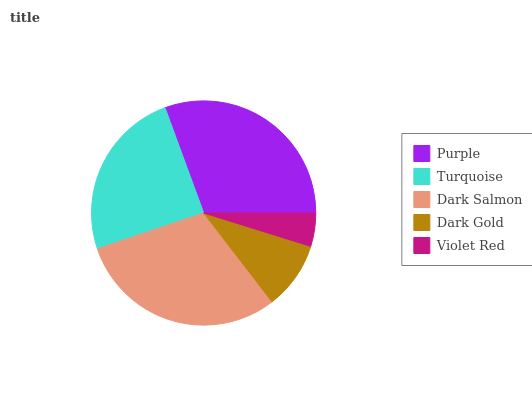Is Violet Red the minimum?
Answer yes or no. Yes. Is Purple the maximum?
Answer yes or no. Yes. Is Turquoise the minimum?
Answer yes or no. No. Is Turquoise the maximum?
Answer yes or no. No. Is Purple greater than Turquoise?
Answer yes or no. Yes. Is Turquoise less than Purple?
Answer yes or no. Yes. Is Turquoise greater than Purple?
Answer yes or no. No. Is Purple less than Turquoise?
Answer yes or no. No. Is Turquoise the high median?
Answer yes or no. Yes. Is Turquoise the low median?
Answer yes or no. Yes. Is Purple the high median?
Answer yes or no. No. Is Dark Gold the low median?
Answer yes or no. No. 